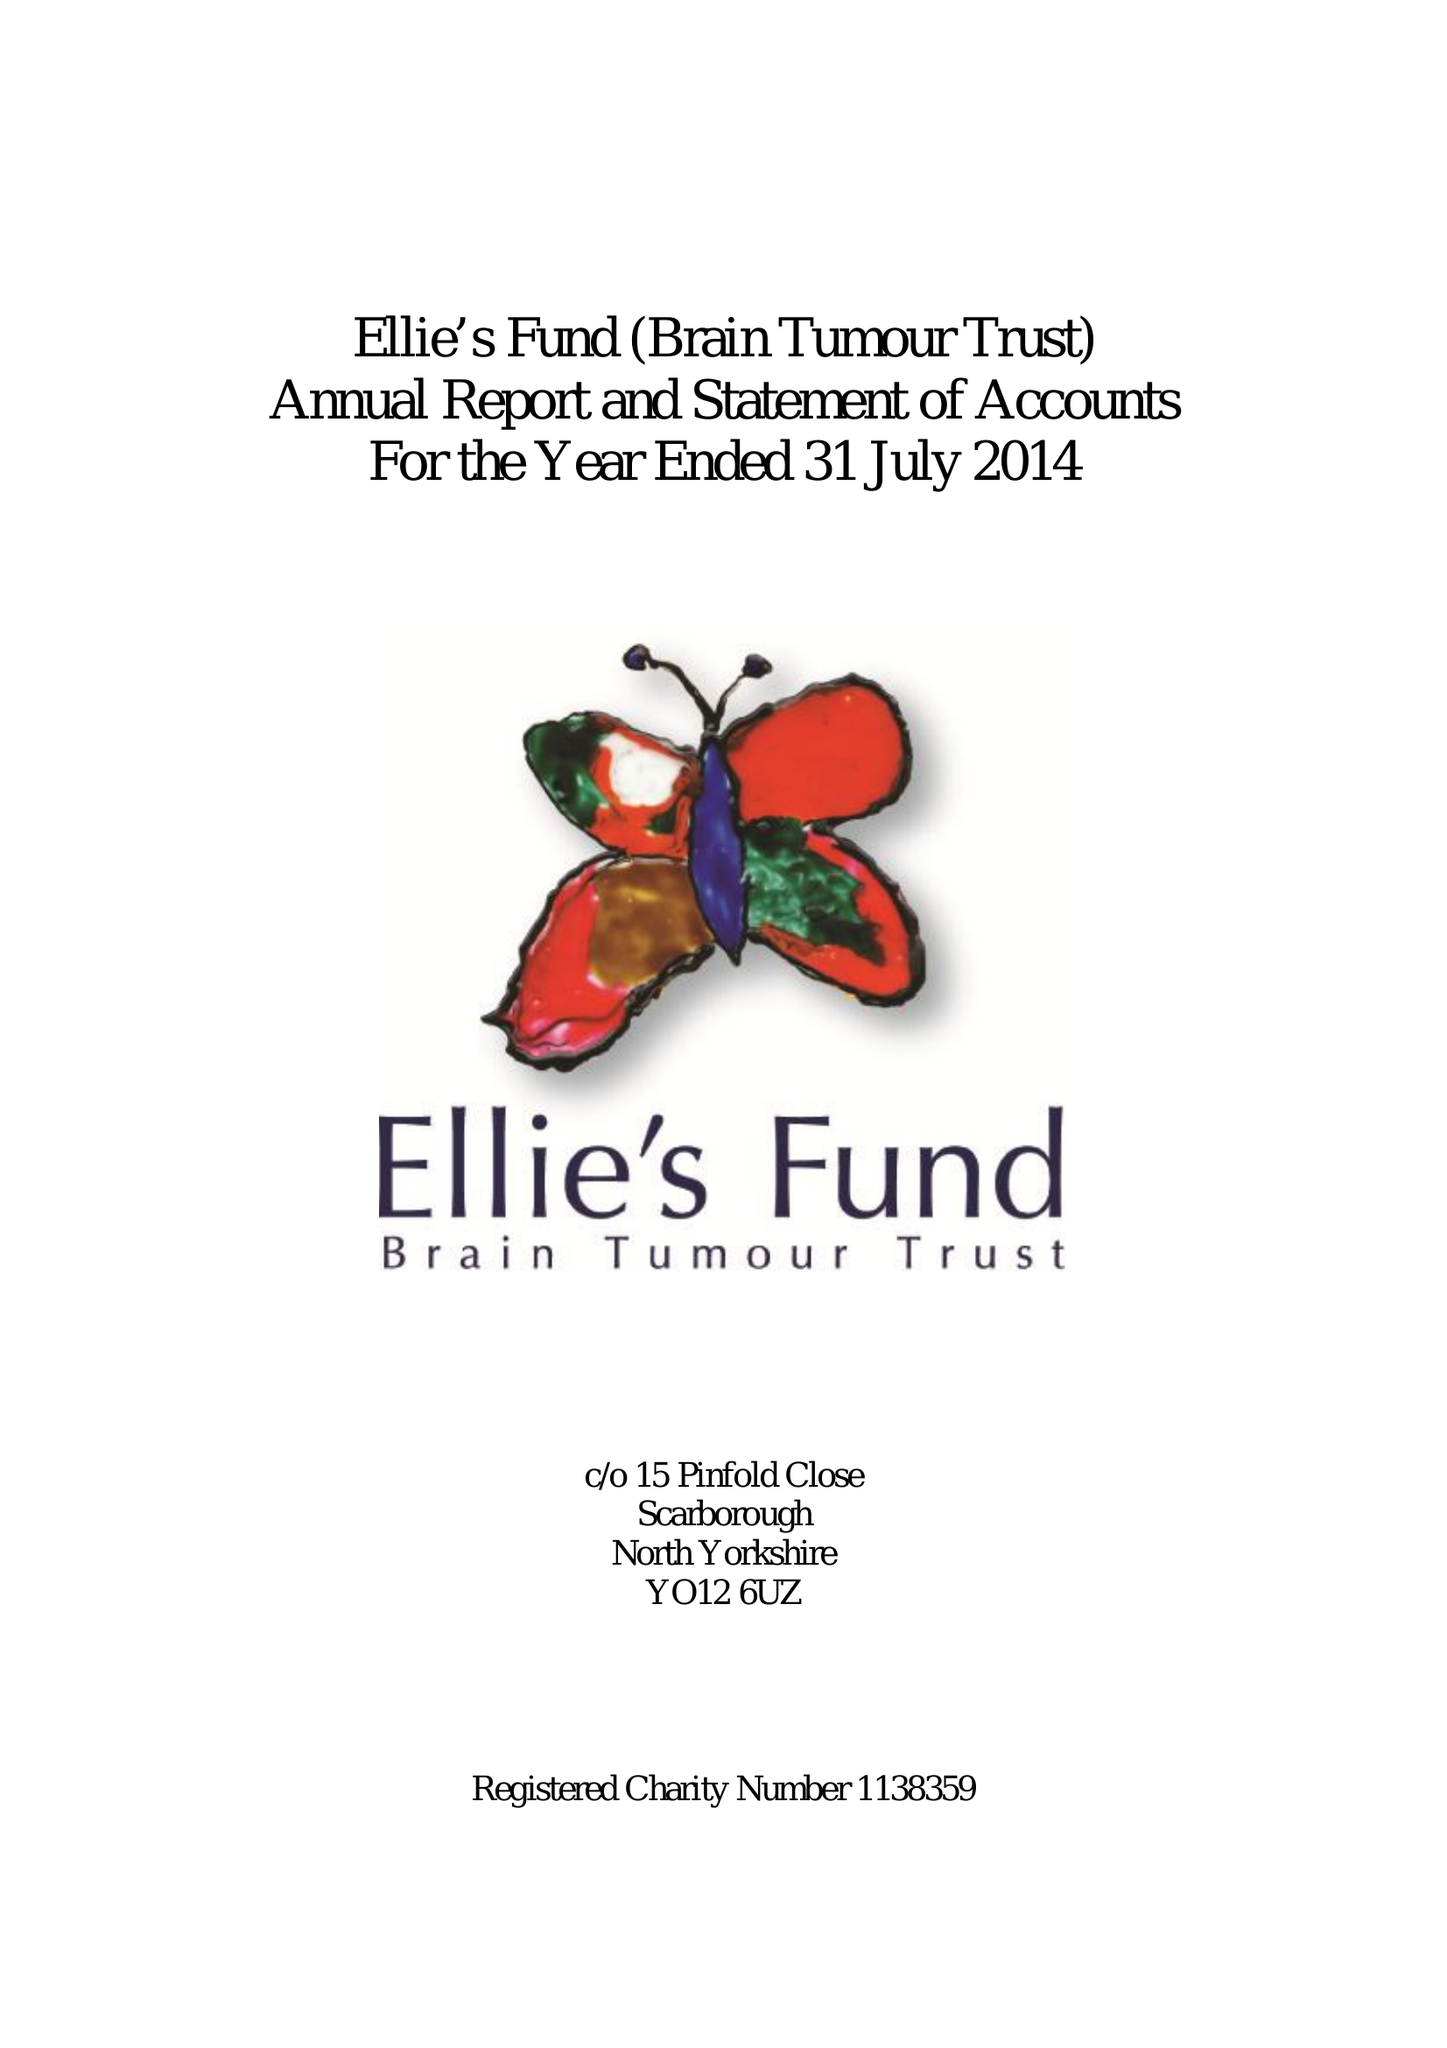What is the value for the charity_name?
Answer the question using a single word or phrase. Ellie's Fund (Brain Tumour Trust) 